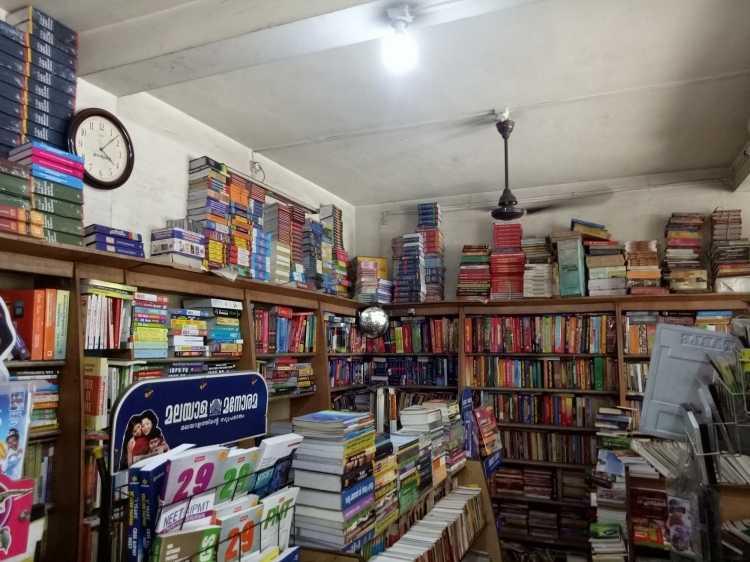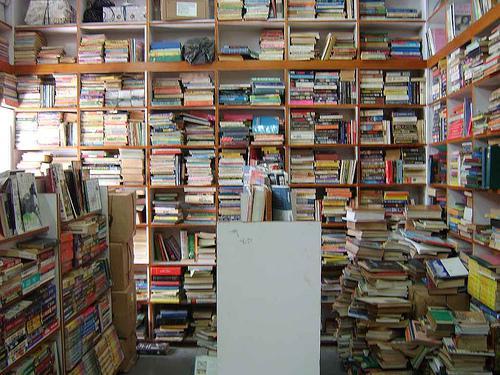The first image is the image on the left, the second image is the image on the right. Considering the images on both sides, is "A bookstore image includes a green balloon and a variety of green signage." valid? Answer yes or no. No. 